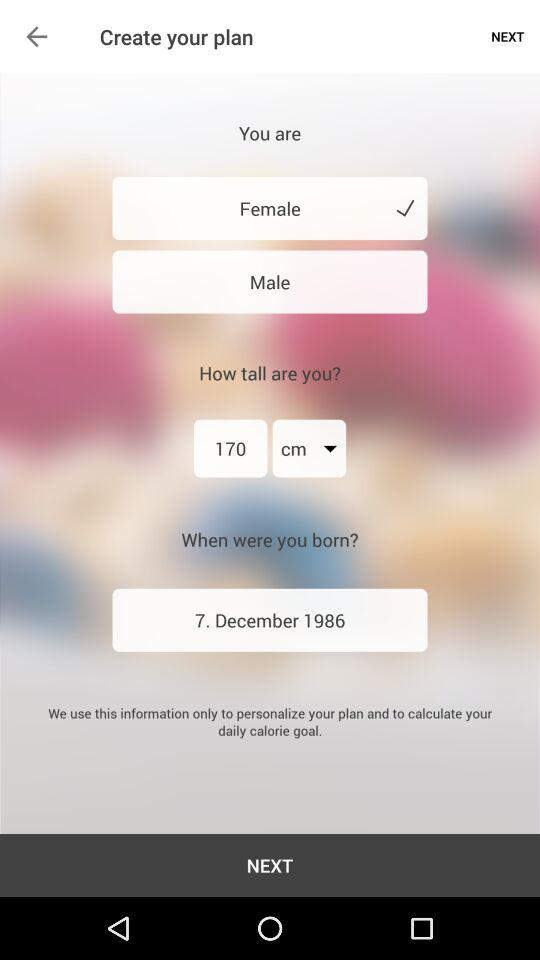What is the height? The height is 170 centimeters. 